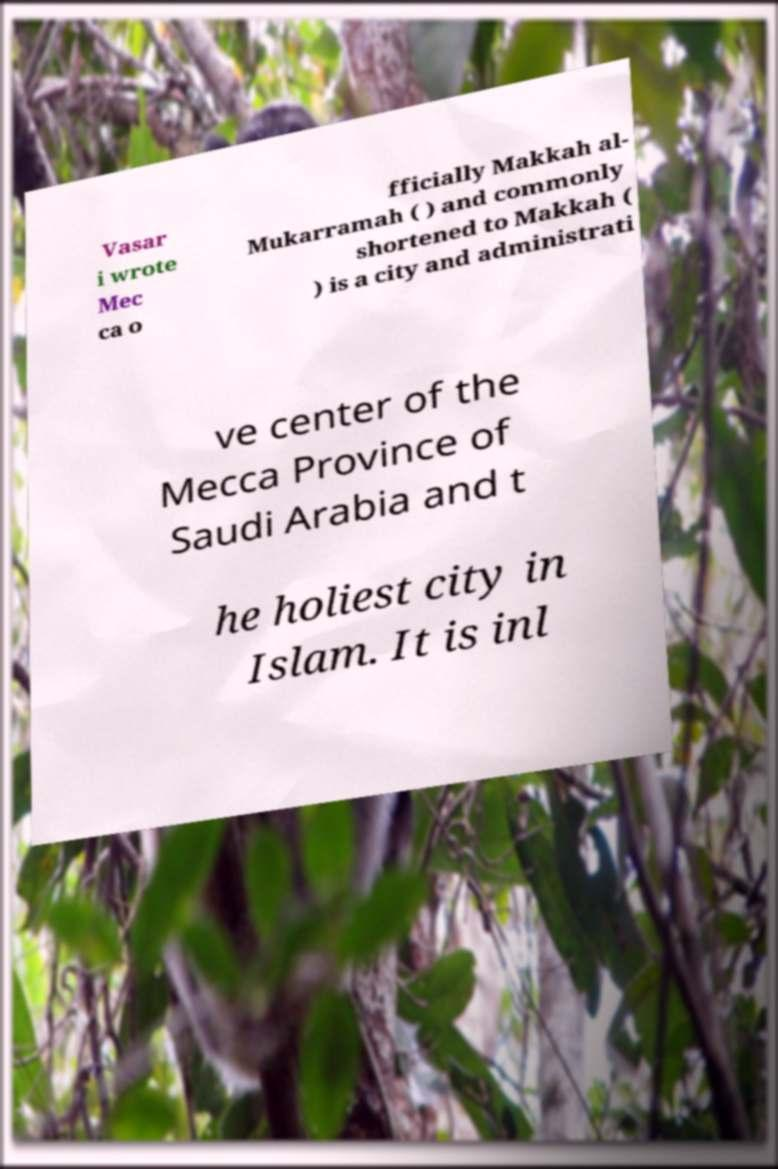Please identify and transcribe the text found in this image. Vasar i wrote Mec ca o fficially Makkah al- Mukarramah ( ) and commonly shortened to Makkah ( ) is a city and administrati ve center of the Mecca Province of Saudi Arabia and t he holiest city in Islam. It is inl 